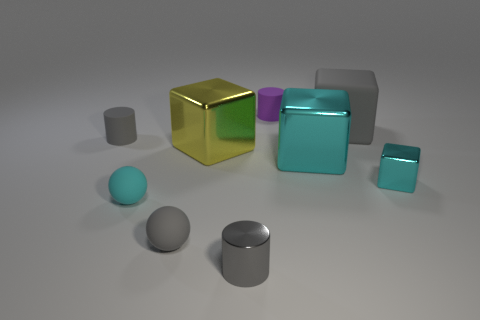Subtract 1 cubes. How many cubes are left? 3 Subtract all purple cylinders. Subtract all cyan balls. How many cylinders are left? 2 Subtract all spheres. How many objects are left? 7 Add 6 tiny cyan matte balls. How many tiny cyan matte balls exist? 7 Subtract 0 purple blocks. How many objects are left? 9 Subtract all yellow matte things. Subtract all tiny cyan shiny things. How many objects are left? 8 Add 2 gray rubber spheres. How many gray rubber spheres are left? 3 